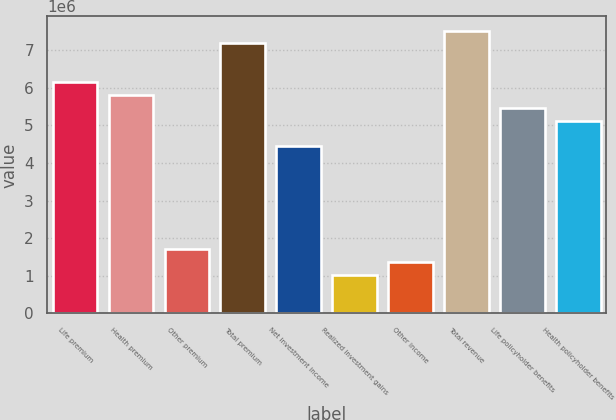<chart> <loc_0><loc_0><loc_500><loc_500><bar_chart><fcel>Life premium<fcel>Health premium<fcel>Other premium<fcel>Total premium<fcel>Net investment income<fcel>Realized investment gains<fcel>Other income<fcel>Total revenue<fcel>Life policyholder benefits<fcel>Health policyholder benefits<nl><fcel>6.15812e+06<fcel>5.816e+06<fcel>1.71059e+06<fcel>7.18447e+06<fcel>4.44753e+06<fcel>1.02635e+06<fcel>1.36847e+06<fcel>7.52659e+06<fcel>5.47388e+06<fcel>5.13177e+06<nl></chart> 